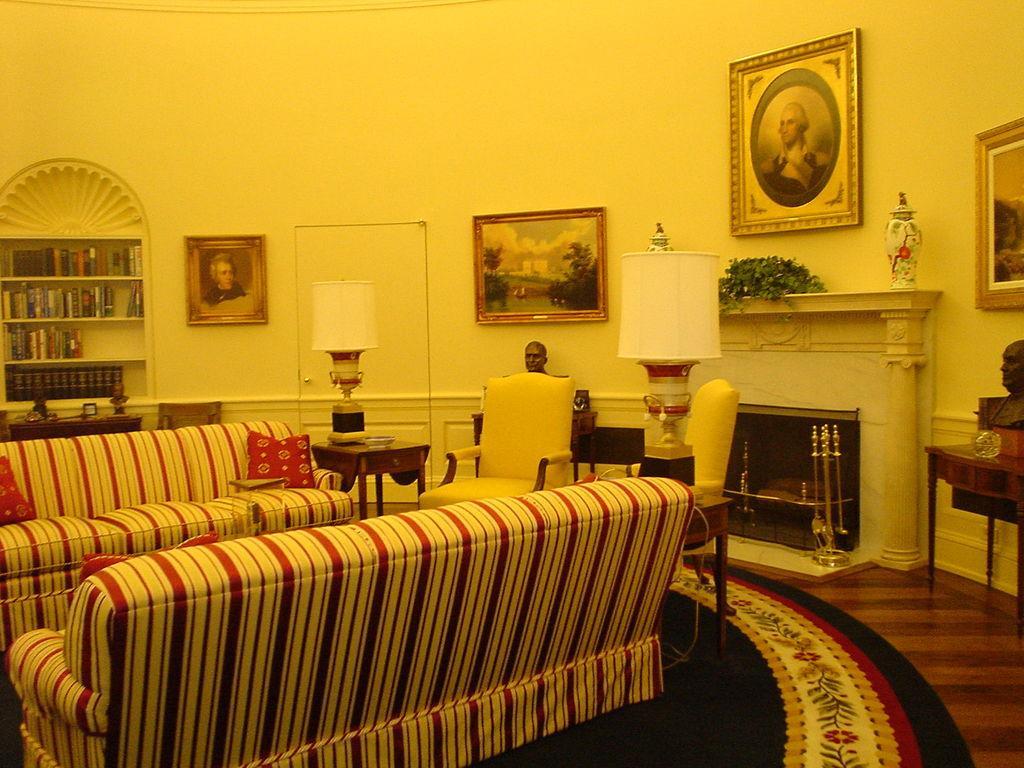Could you give a brief overview of what you see in this image? This is wall,this is photo frame,this is lamp,this is sofa,this is person in the frame,this are books in the shelf,this is table and this is flower and this is again a table. 